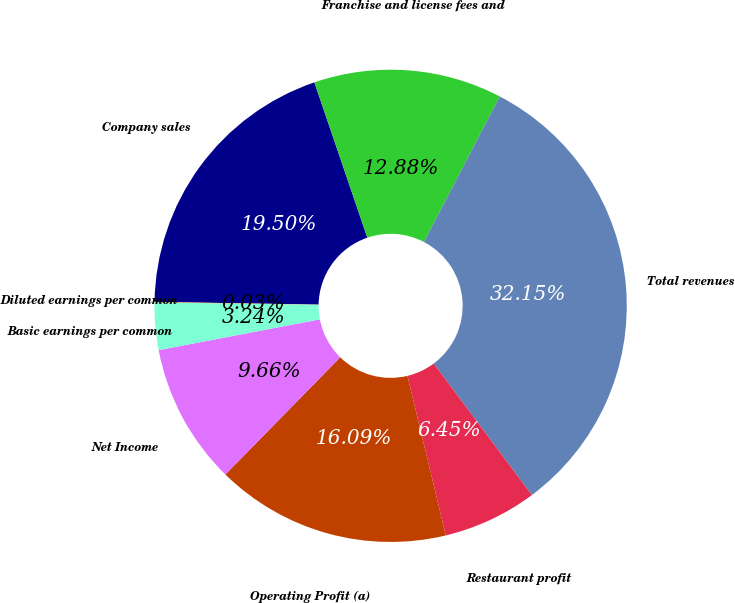<chart> <loc_0><loc_0><loc_500><loc_500><pie_chart><fcel>Company sales<fcel>Franchise and license fees and<fcel>Total revenues<fcel>Restaurant profit<fcel>Operating Profit (a)<fcel>Net Income<fcel>Basic earnings per common<fcel>Diluted earnings per common<nl><fcel>19.5%<fcel>12.88%<fcel>32.15%<fcel>6.45%<fcel>16.09%<fcel>9.66%<fcel>3.24%<fcel>0.03%<nl></chart> 